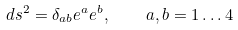Convert formula to latex. <formula><loc_0><loc_0><loc_500><loc_500>d s ^ { 2 } = \delta _ { a b } e ^ { a } e ^ { b } , \quad a , b = 1 \dots 4</formula> 